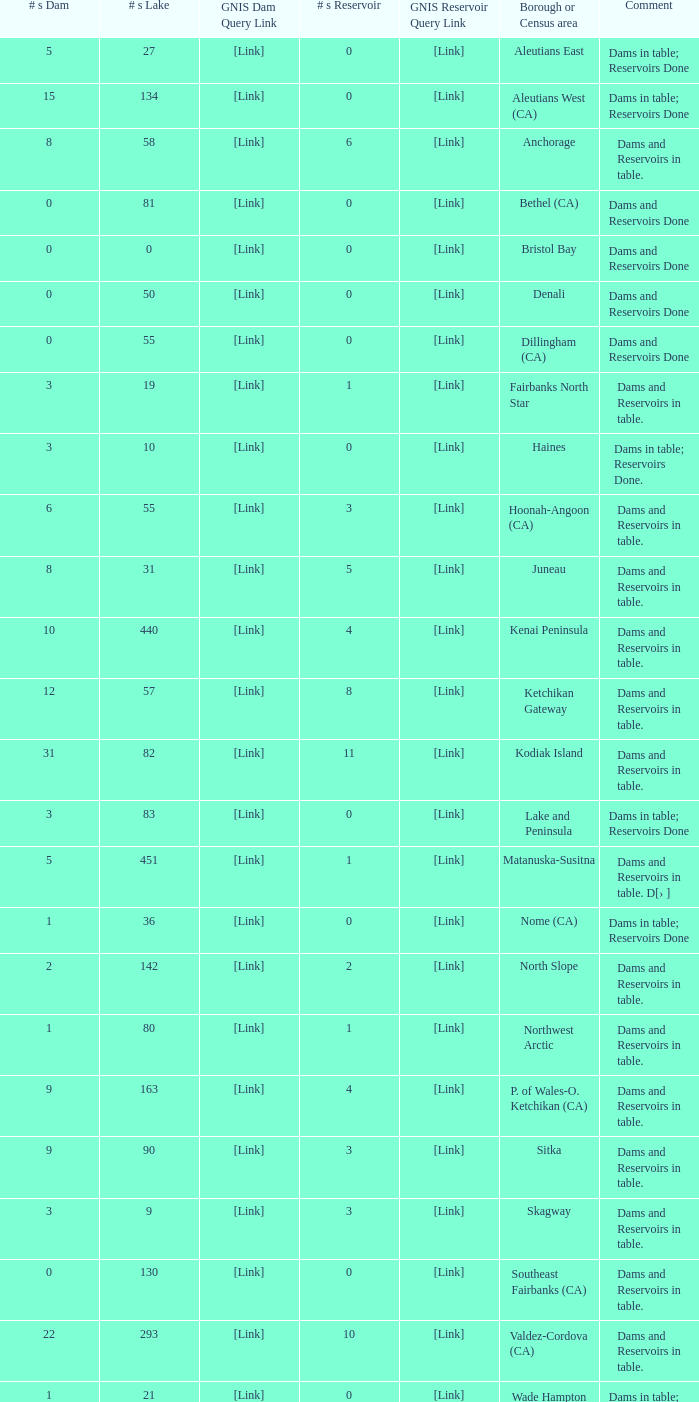Name the minimum number of reservoir for gnis query link where numbers lake gnis query link being 60 5.0. 